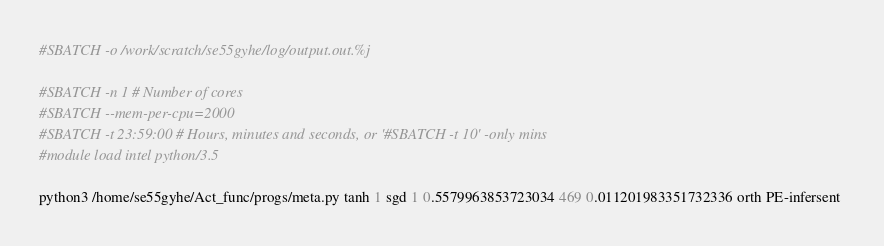Convert code to text. <code><loc_0><loc_0><loc_500><loc_500><_Bash_>#SBATCH -o /work/scratch/se55gyhe/log/output.out.%j

#SBATCH -n 1 # Number of cores
#SBATCH --mem-per-cpu=2000
#SBATCH -t 23:59:00 # Hours, minutes and seconds, or '#SBATCH -t 10' -only mins
#module load intel python/3.5

python3 /home/se55gyhe/Act_func/progs/meta.py tanh 1 sgd 1 0.5579963853723034 469 0.011201983351732336 orth PE-infersent 

</code> 